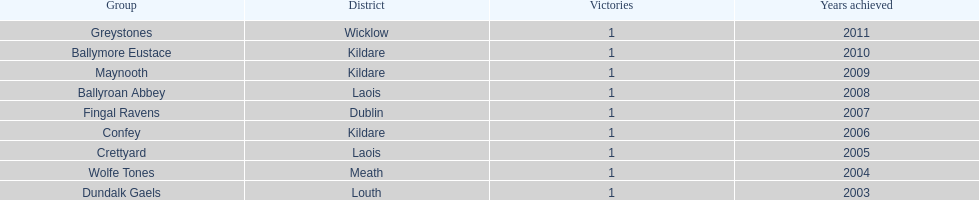Ballymore eustace is from the same county as what team that won in 2009? Maynooth. 